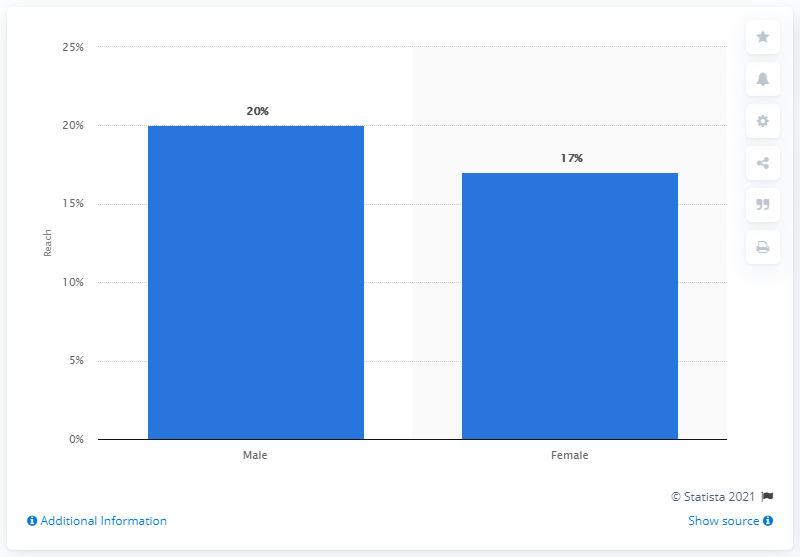Point out several critical features in this image. According to a recent study, approximately 17% of female internet users use WhatsApp. 